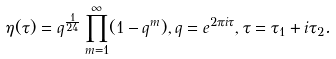<formula> <loc_0><loc_0><loc_500><loc_500>\eta ( \tau ) = q ^ { \frac { 1 } { 2 4 } } \prod _ { m = 1 } ^ { \infty } ( 1 - q ^ { m } ) , q = e ^ { 2 \pi i \tau } , \tau = \tau _ { 1 } + i \tau _ { 2 } .</formula> 